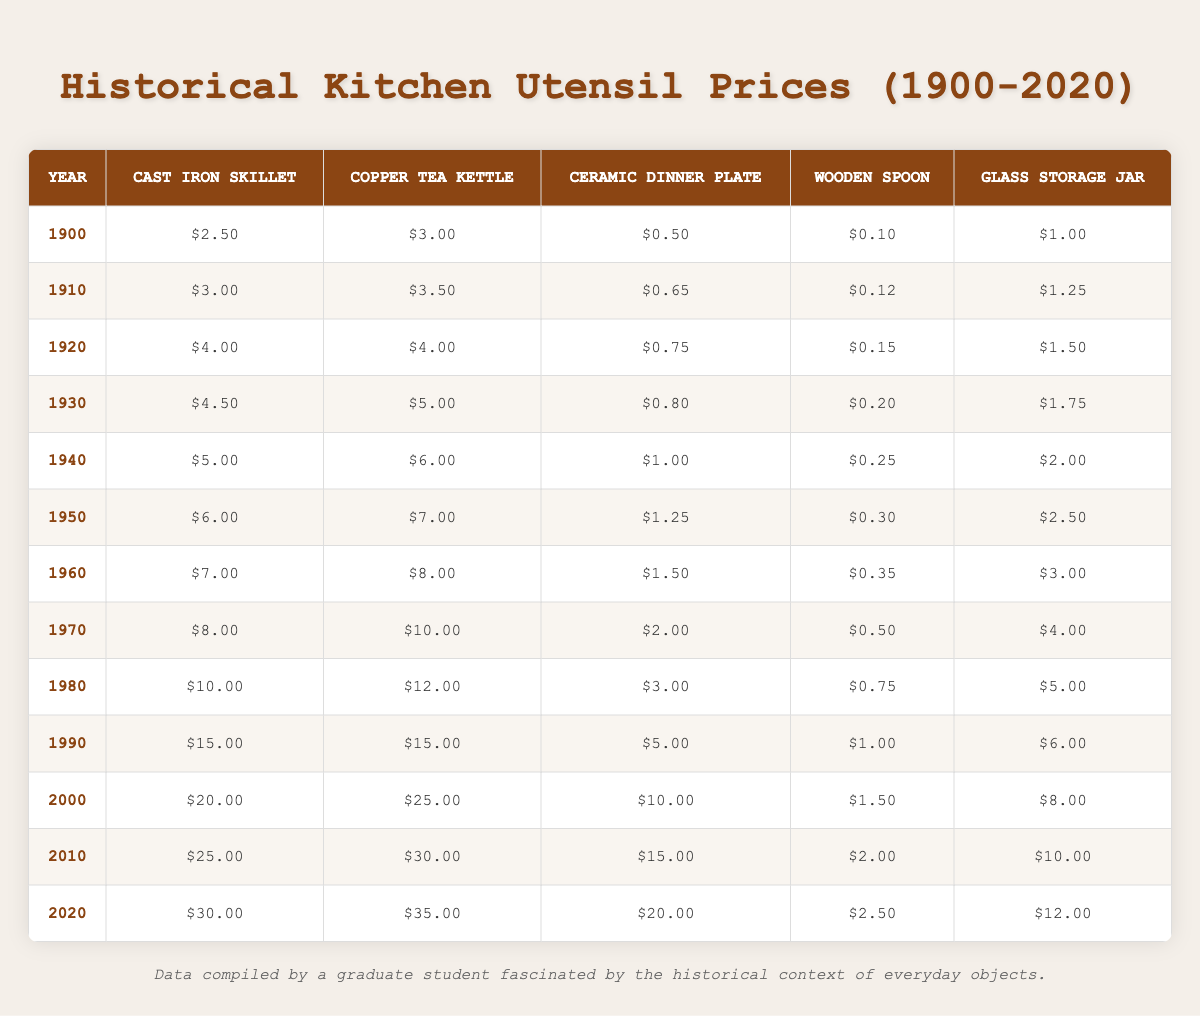What was the price of a cast iron skillet in 1950? The table directly shows the price of a cast iron skillet in 1950, which is listed as $6.00.
Answer: 6.00 What is the difference in price for a copper tea kettle between 1900 and 2020? The price of a copper tea kettle in 1900 is $3.00 and in 2020 it is $35.00. Subtracting these gives $35.00 - $3.00 = $32.00.
Answer: 32.00 Was the price of a glass storage jar higher in 2000 than in 1990? In 2000, the price of a glass storage jar is $8.00, and in 1990, it is $6.00. Since $8.00 > $6.00, the statement is true.
Answer: Yes What was the average price of a ceramic dinner plate from 1900 to 2020? We can calculate the average by summing the prices of the ceramic dinner plate across all years and dividing by the number of years (121.50 / 13 = 9.38). The total is $121.50 and there are 13 data points.
Answer: 9.38 Which utensil showed the most significant price increase from 1960 to 1970? Comparing the price changes, the cast iron skillet went from $7.00 to $8.00 (increase of $1.00), copper tea kettle from $8.00 to $10.00 ($2.00 increase), ceramic dinner plate from $1.50 to $2.00 ($0.50 increase), wooden spoon from $0.35 to $0.50 ($0.15 increase) and glass storage jar from $3.00 to $4.00 ($1.00 increase). The copper tea kettle has the highest increase of $2.00.
Answer: Copper tea kettle What year had the lowest recorded price for a wooden spoon? By scanning the table, the lowest price for a wooden spoon is identified as $0.10 in 1900.
Answer: 1900 How much more expensive was a copper tea kettle in 2010 compared to 1940? In 2010, the copper tea kettle cost $30.00 and in 1940 it cost $6.00. The difference is $30.00 - $6.00 = $24.00.
Answer: 24.00 In which decade did the price of a glass storage jar first exceed $5.00? The price of a glass storage jar exceeds $5.00 starting in 1980, when it's priced at $5.00. It was still less than $5.00 in 1970, where it was priced at $4.00.
Answer: 1980 What is the median price of the cast iron skillet across all decades? Listing the prices of the cast iron skillet from all years (2.50, 3.00, 4.00, 4.50, 5.00, 6.00, 7.00, 8.00, 10.00, 15.00, 20.00, 25.00, 30.00) in increasing order and finding the middle value of the 13 prices gives us the median, which is $10.00 (the 7th value).
Answer: 10.00 What kitchen utensil consistently had the lowest price throughout the decades or had its lowest price at the same decade? The wooden spoon consistently had the lowest price across all decades, with its lowest price being $0.10 in 1900 and increasing each decade.
Answer: Wooden spoon From 1900 to 2020, how many times did the price of a ceramic dinner plate double? The price increased from $0.50 in 1900 to $20.00 in 2020. The first doubling occurs when it goes from $0.50 (doubled to $1.00) in 1940, the next doubling to $2.00 in 1970, then to $4.00 in 1990, and finally to $20.00 in 2020. Thus, it doubled three times.
Answer: 3 times 